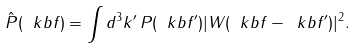<formula> <loc_0><loc_0><loc_500><loc_500>\hat { P } ( \ k b f ) = \int d ^ { 3 } k ^ { \prime } \, P ( \ k b f ^ { \prime } ) | W ( \ k b f - \ k b f ^ { \prime } ) | ^ { 2 } .</formula> 